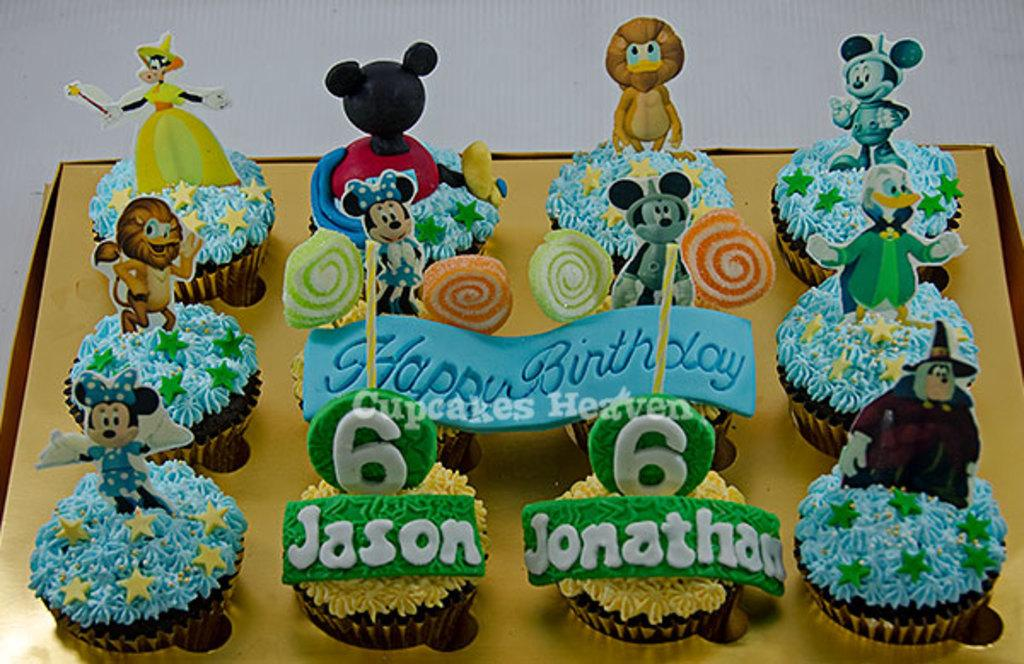What is the main piece of furniture in the image? There is a table in the image. What is placed on the table? There is a box of cupcakes, candies, and toys on the table. Can you describe the type of food on the table? The food on the table includes cupcakes and candies. What else can be found on the table besides food? There are also toys on the table. How many cherries are on top of the cupcakes in the image? There is no mention of cherries in the image; the cupcakes are not described as having cherries on top. What type of learning activity is taking place in the image? There is no indication of a learning activity in the image; it primarily features a table with cupcakes, candies, and toys. 